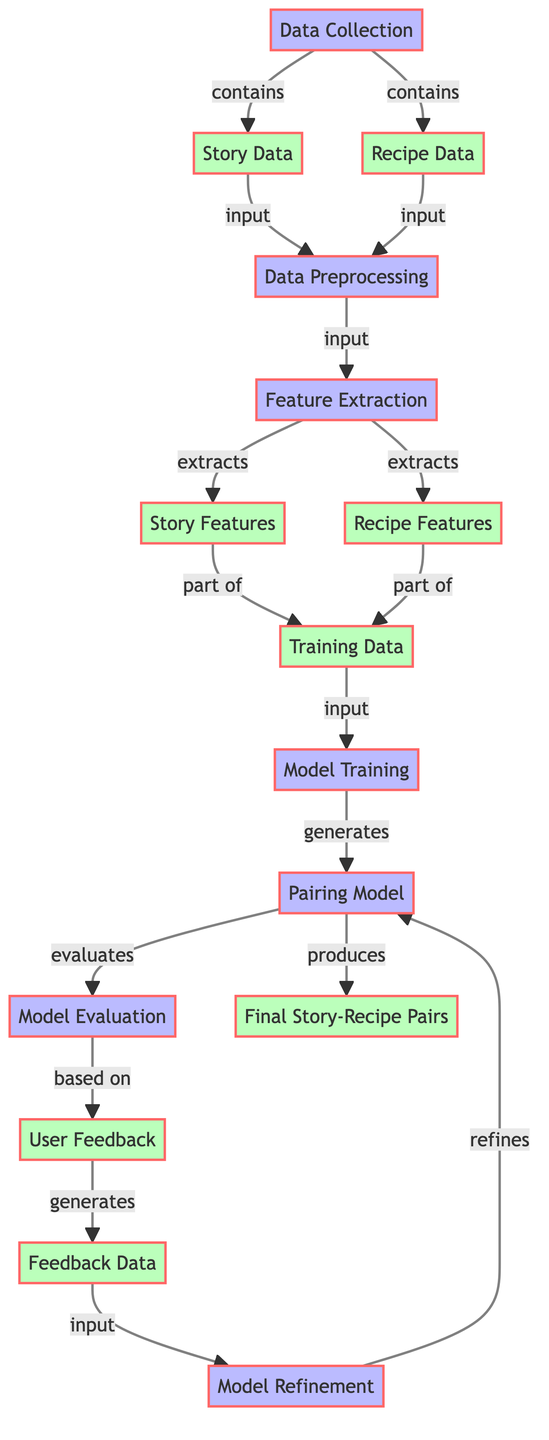what is the first step in the algorithm? The first step in the algorithm is "Data Collection." This is identified as the initial process node from which subsequent actions, such as gathering "Story Data" and "Recipe Data," branch off.
Answer: Data Collection how many data types are represented in the diagram? The diagram includes two distinct data types: "Story Data" and "Recipe Data." These are both referenced as output components of the "Data Collection" node.
Answer: Two what action follows feature extraction? The action that follows "Feature Extraction" is "Model Training." This is indicated by the direct connection leading from "Feature Extraction" to "Model Training."
Answer: Model Training what do story features and recipe features form? "Story Features" and "Recipe Features" are both parts of "Training Data." This is derived from the labels indicating the features feed into the training data used for the model.
Answer: Training Data how is user feedback integrated into the model? "User Feedback" is utilized in the "Model Evaluation" process, as it directly informs how the model is assessed based on user insights, leading to "Feedback Data."
Answer: Model Evaluation what produces final story-recipe pairs? The "Pairing Model" produces "Final Story-Recipe Pairs." This is illustrated by the directed edge showing that the outcome of the "Pairing Model" leads directly to this final output.
Answer: Pairing Model which step comes after model training? The step that comes after "Model Training" is "Model Evaluation." This is clearly indicated in the flow direction from the training process to the evaluation phase.
Answer: Model Evaluation what is the role of feedback data in the algorithm? "Feedback Data" plays a critical role in "Model Refinement," as it serves as input that helps refine and improve the "Pairing Model." This connection shows the iterative process of enhancing the model based on collected feedback.
Answer: Model Refinement 